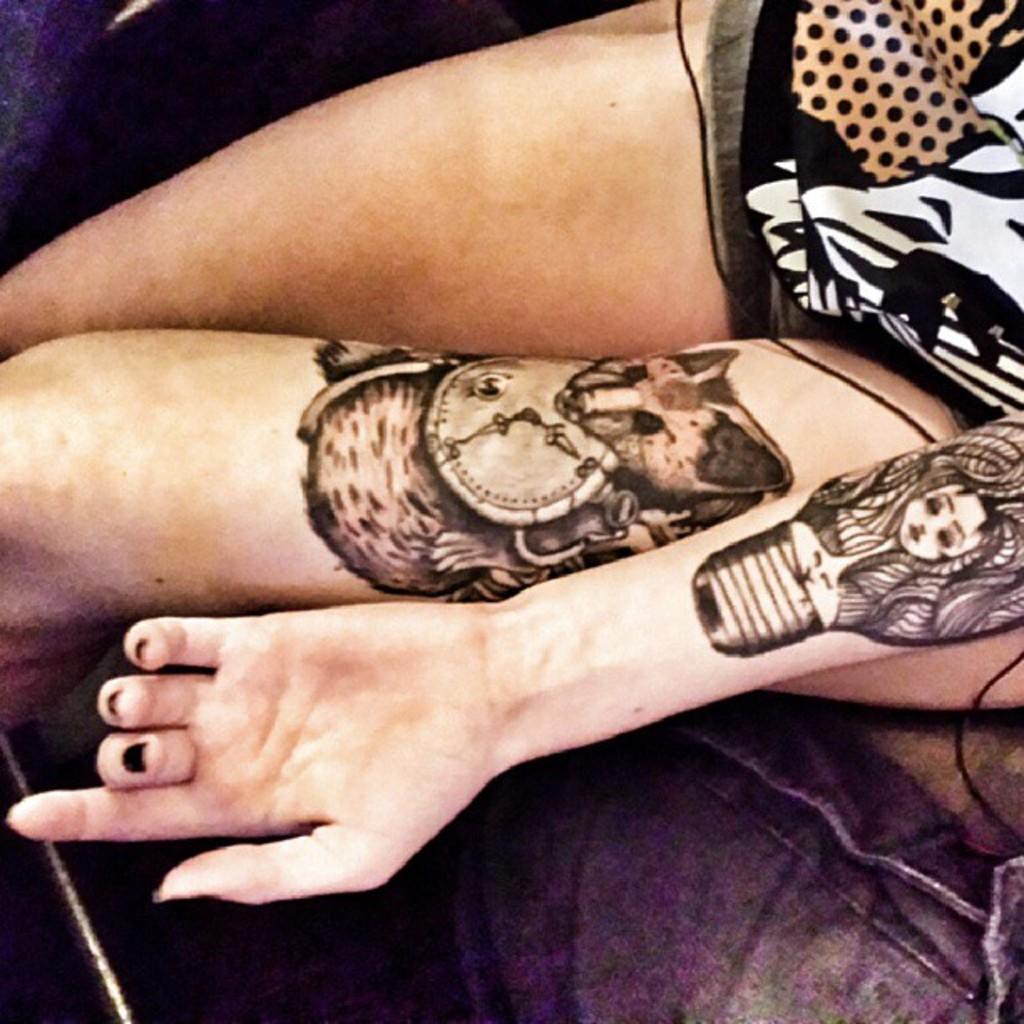Describe this image in one or two sentences. In this picture I can see a person sitting. There are tattoos on the hand and on the thigh of a person. 